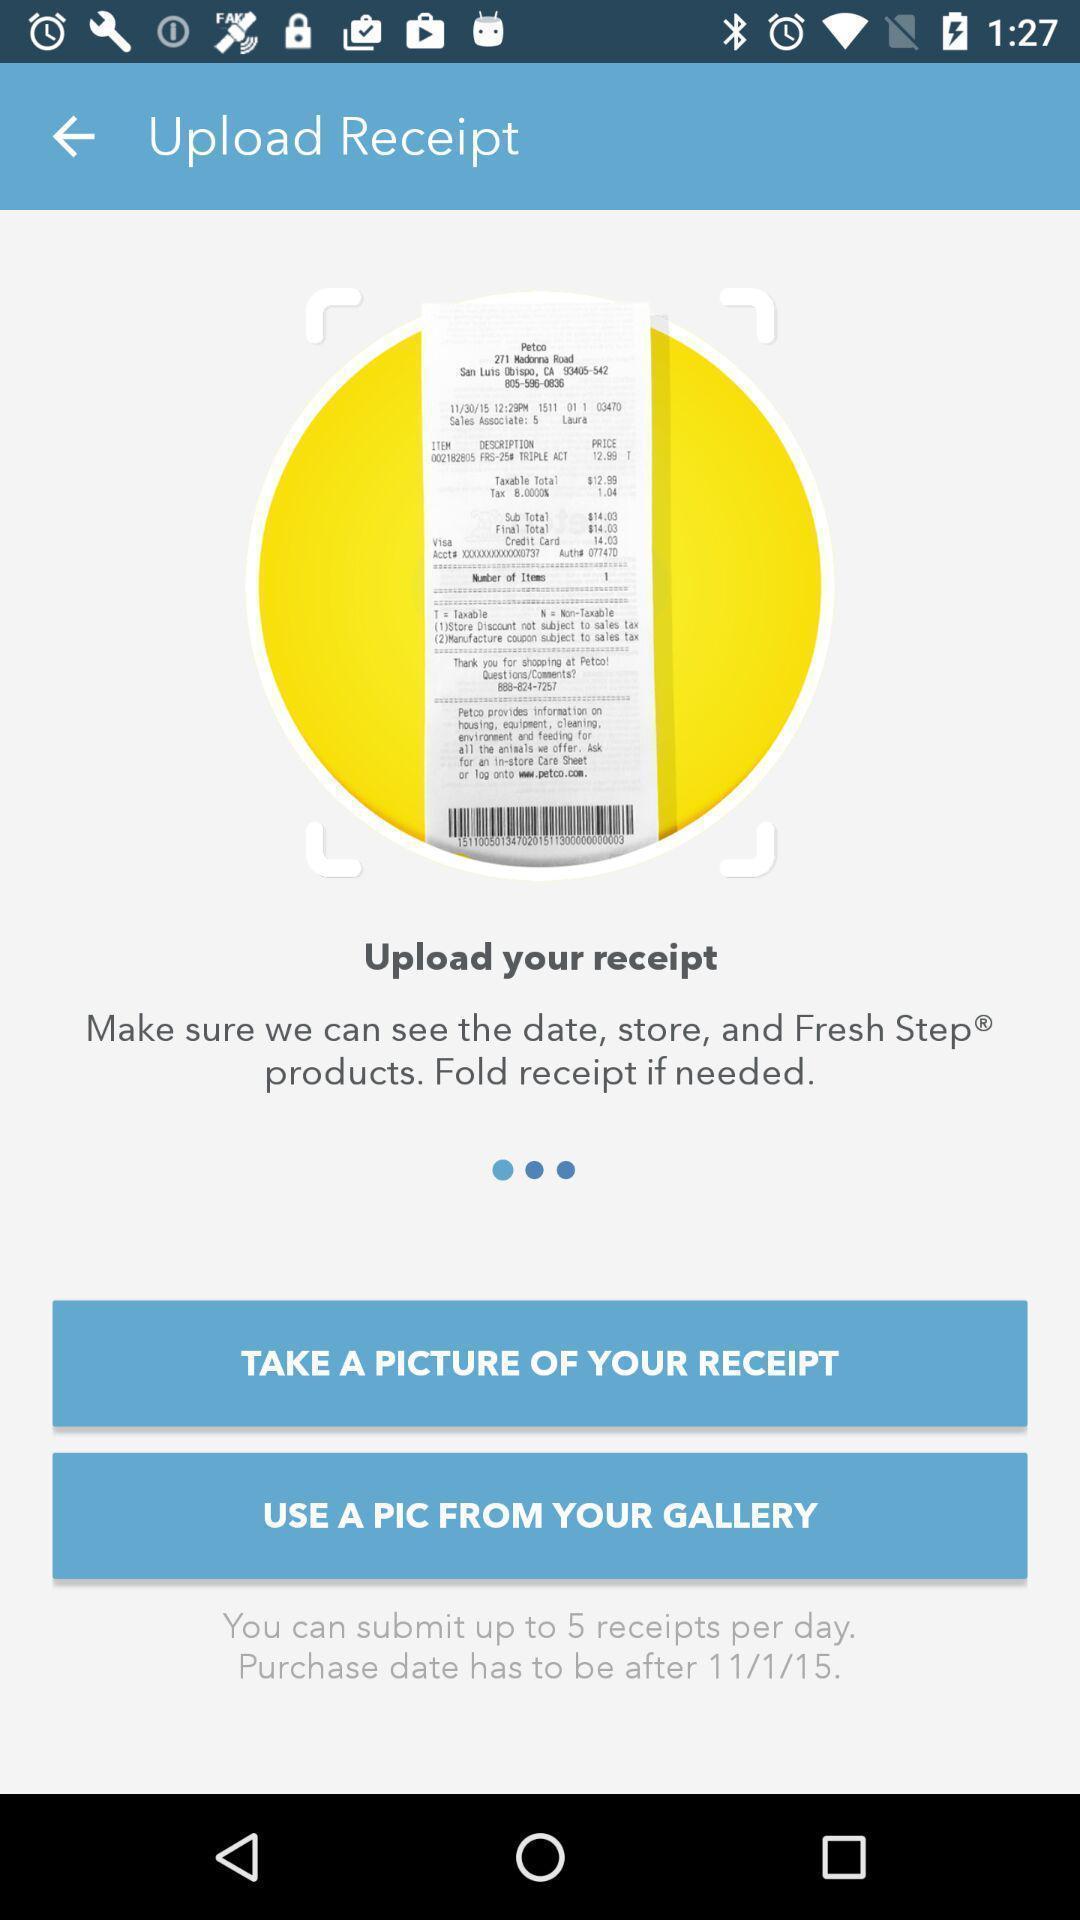Tell me what you see in this picture. Update notification of the receipt in the application. 